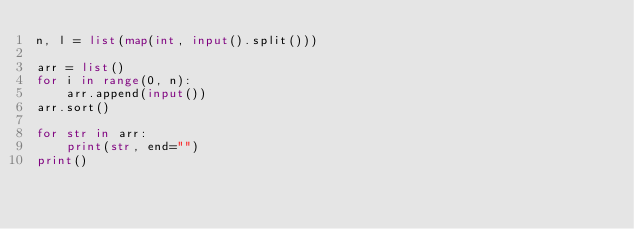Convert code to text. <code><loc_0><loc_0><loc_500><loc_500><_Python_>n, l = list(map(int, input().split()))

arr = list()
for i in range(0, n):
    arr.append(input())
arr.sort()

for str in arr:
    print(str, end="")
print()</code> 